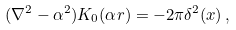<formula> <loc_0><loc_0><loc_500><loc_500>( \nabla ^ { 2 } - \alpha ^ { 2 } ) K _ { 0 } ( \alpha { r } ) = - 2 \pi \delta ^ { 2 } ( x ) \, ,</formula> 